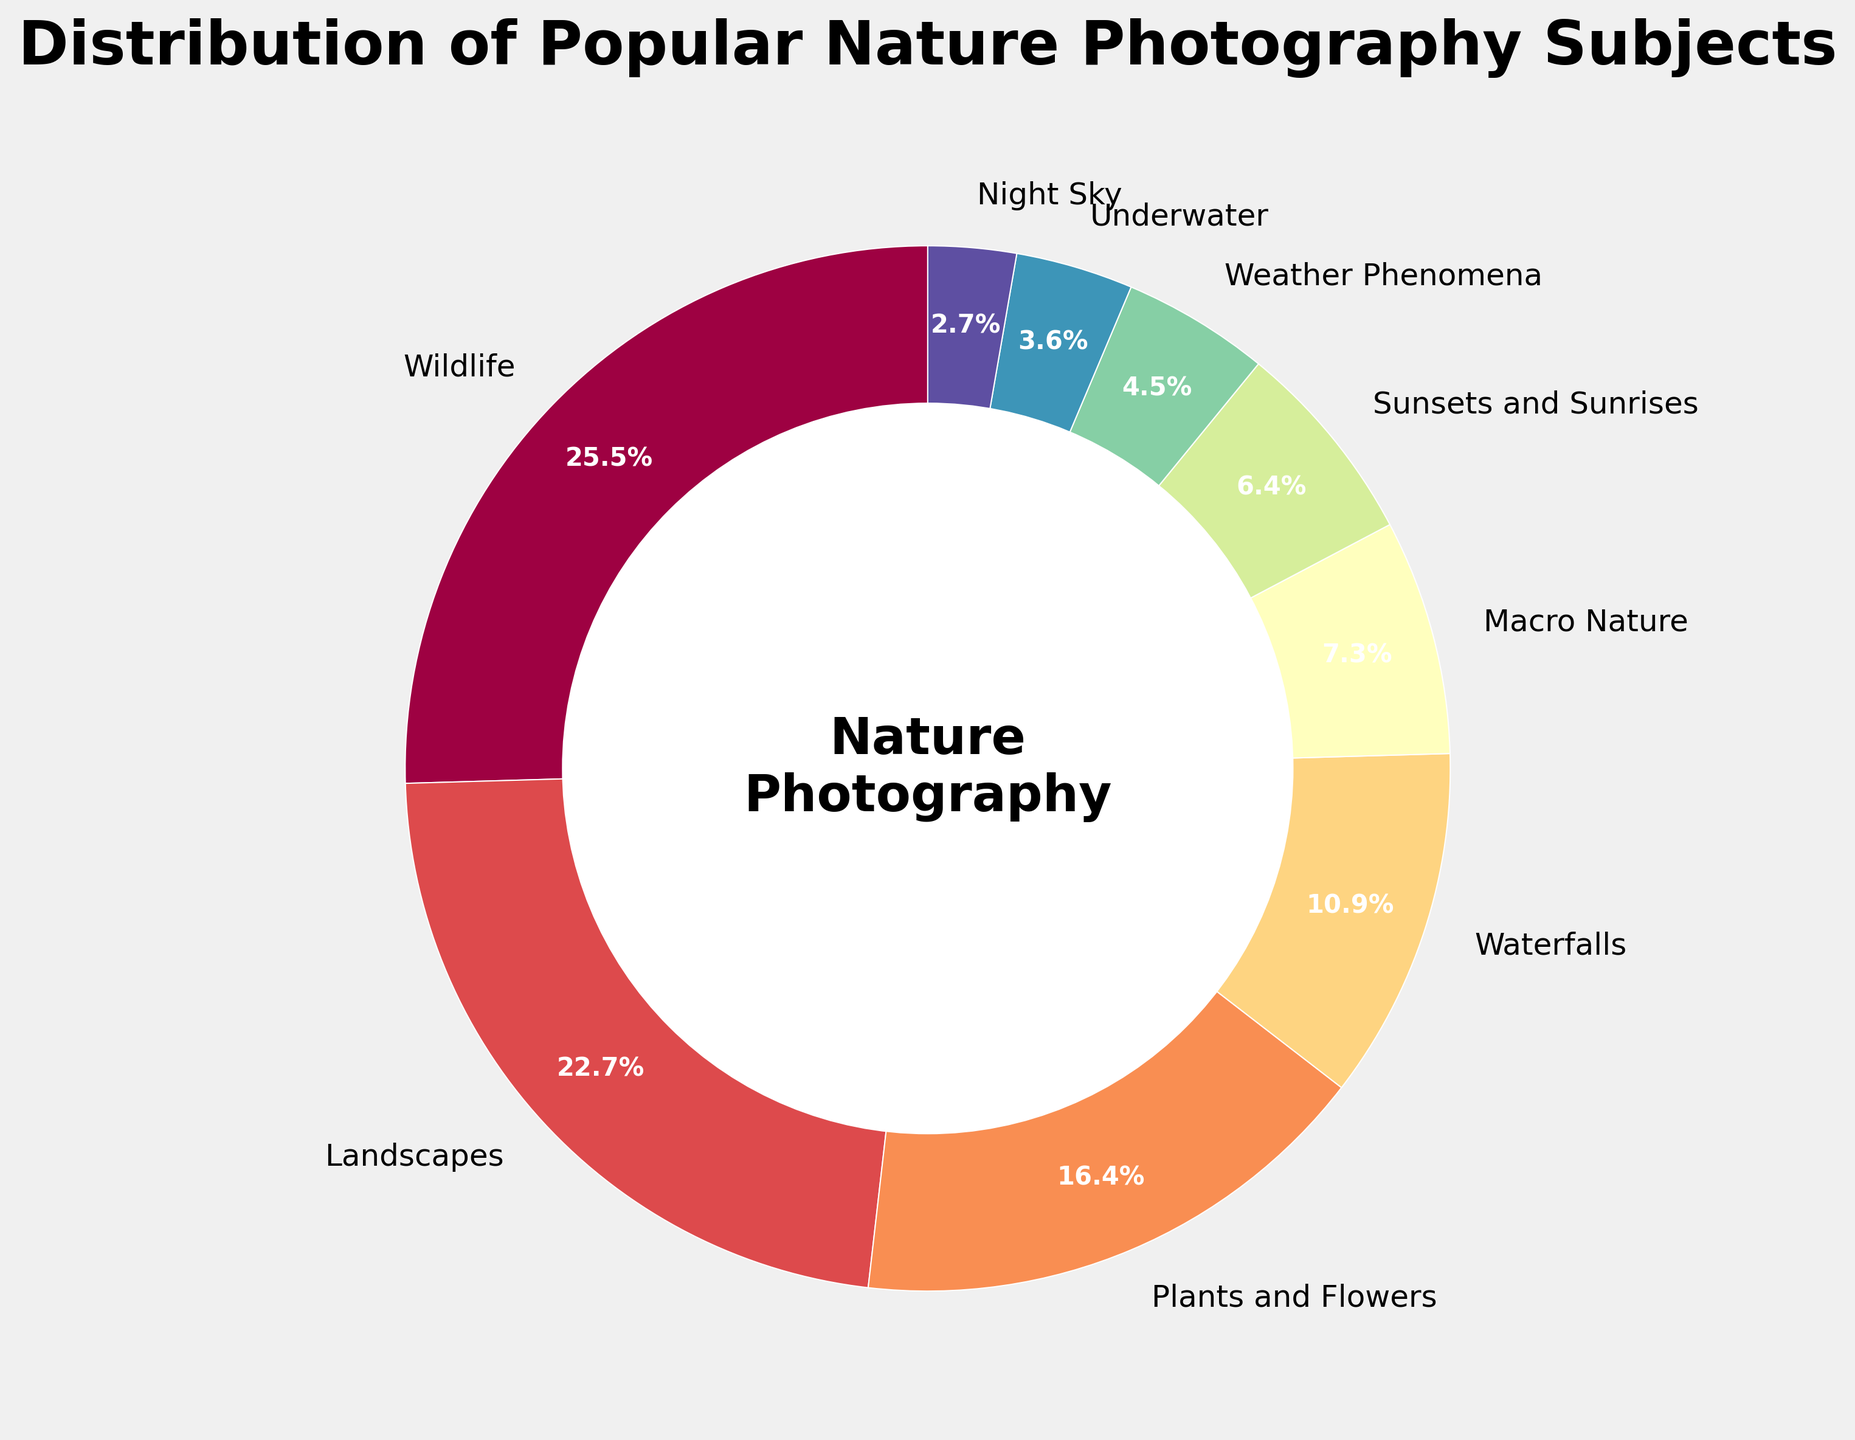Which subject has the highest percentage? By looking at the pie chart, the slice with the largest size corresponds to Wildlife, which is 28%.
Answer: Wildlife What is the combined percentage of Landscapes and Waterfalls? Landscapes are 25% and Waterfalls are 12%. Adding them together, 25 + 12 = 37%.
Answer: 37% Which subject has the lowest percentage, and what is it? The smallest slice in the pie chart corresponds to Night Sky, which has a percentage of 3%.
Answer: Night Sky, 3% How do the percentages of Macro Nature and Sunsets and Sunrises compare? Macro Nature is 8% and Sunsets and Sunrises is 7%. Comparing the two, Macro Nature has a higher percentage by 1%.
Answer: Macro Nature > Sunsets and Sunrises If you were to combine the percentages of Weather Phenomena and Underwater, would it exceed the percentage of Plants and Flowers? Weather Phenomena is 5% and Underwater is 4%. Combined, 5 + 4 = 9%. Plants and Flowers is 18%. So, 9% is less than 18%.
Answer: No Which subject has a percentage closest to 10%? Checking the slices in the pie chart, Waterfalls has a percentage closest to 10% with a value of 12%.
Answer: Waterfalls What are the total combined percentages of subjects that fall below 10%? The subjects below 10% are Macro Nature (8%), Sunsets and Sunrises (7%), Weather Phenomena (5%), Underwater (4%), and Night Sky (3%). Summing them up, 8 + 7 + 5 + 4 + 3 = 27%.
Answer: 27% Which subject category is represented by the lightest color in the pie chart? Observing the lighter colors typically indicating smaller slices, the lightest color corresponds to the Night Sky slice with 3%.
Answer: Night Sky 